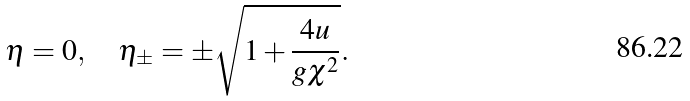Convert formula to latex. <formula><loc_0><loc_0><loc_500><loc_500>\eta = 0 , \quad \eta _ { \pm } = \pm \sqrt { 1 + \frac { 4 u } { g \chi ^ { 2 } } } .</formula> 